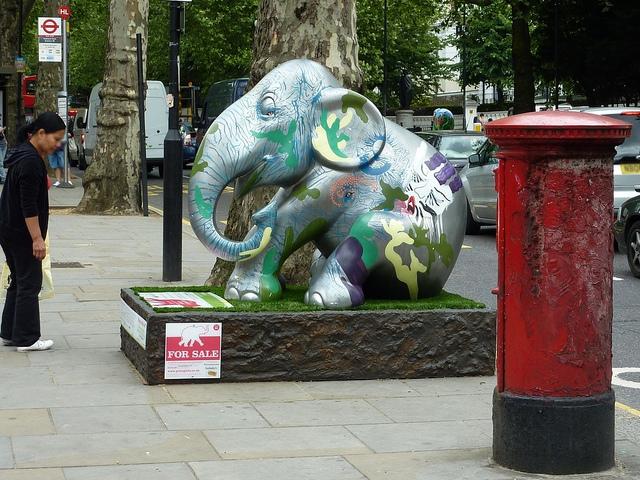What color is the mailbox?
Quick response, please. Red. What color is the hydrant?
Quick response, please. Red. What does the sign offer for sale?
Short answer required. Statue. What color is the hydrants?
Quick response, please. Red. What animal is the statue?
Answer briefly. Elephant. 